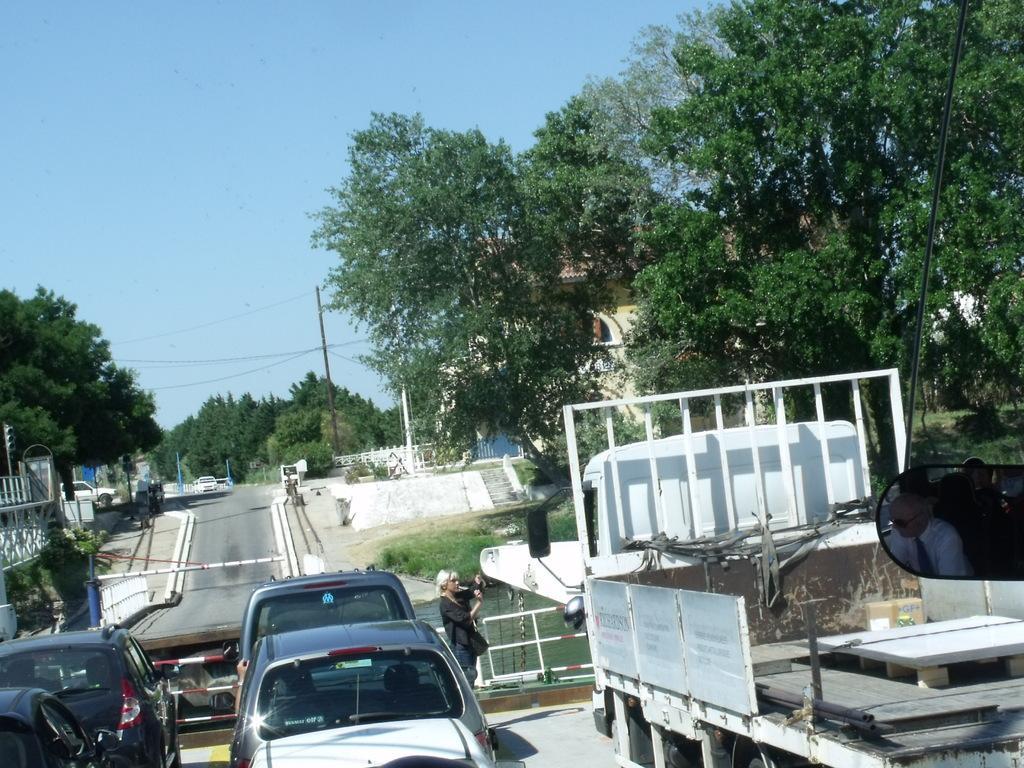In one or two sentences, can you explain what this image depicts? In this picture we can see few vehicles on the road, in front of the vehicles we can find a woman, in the background we can see water, trees, poles and buildings. 